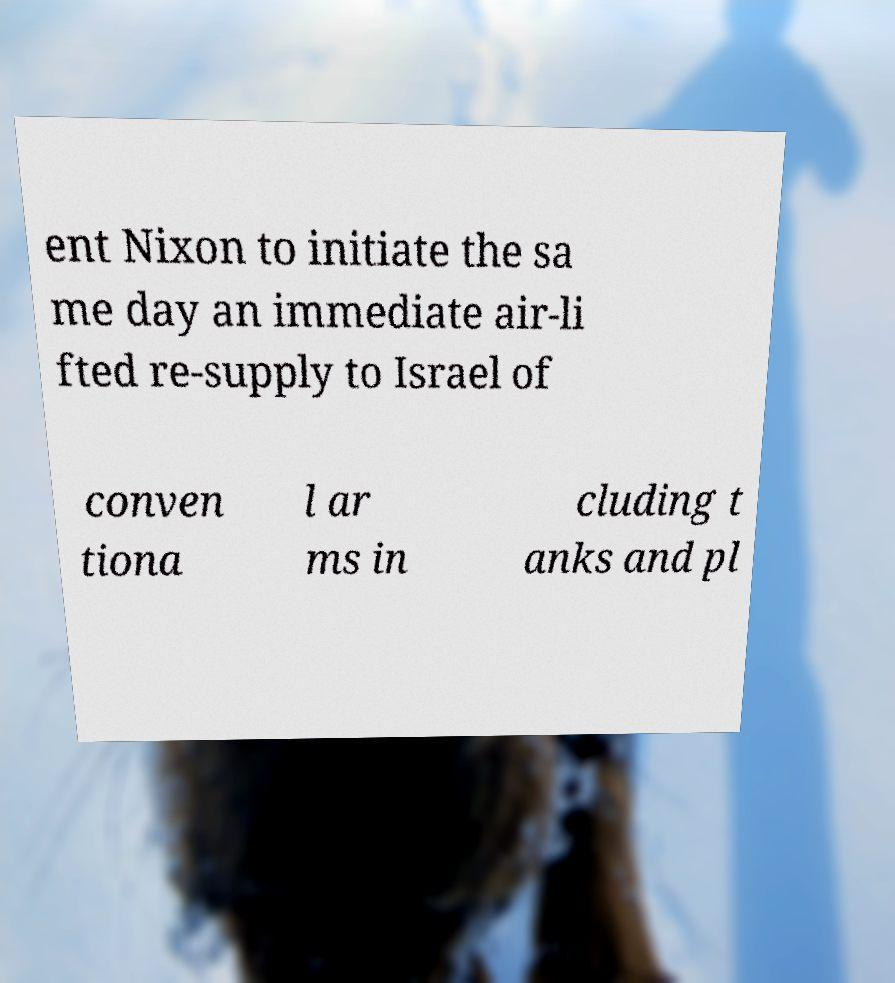Can you accurately transcribe the text from the provided image for me? ent Nixon to initiate the sa me day an immediate air-li fted re-supply to Israel of conven tiona l ar ms in cluding t anks and pl 